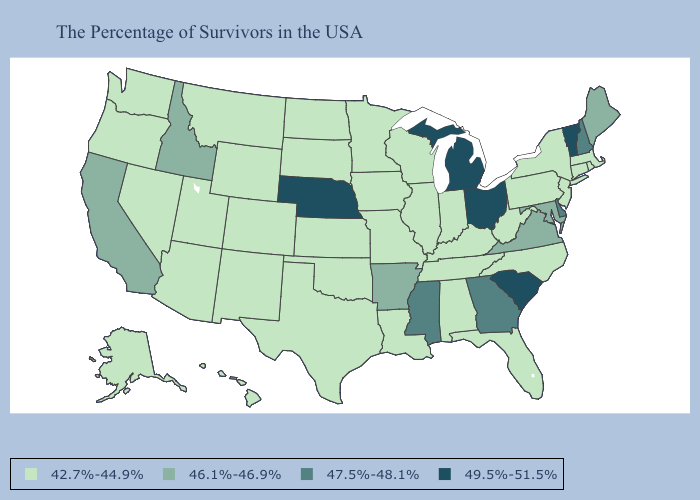Which states have the lowest value in the South?
Give a very brief answer. North Carolina, West Virginia, Florida, Kentucky, Alabama, Tennessee, Louisiana, Oklahoma, Texas. Among the states that border Washington , does Oregon have the highest value?
Short answer required. No. What is the value of Illinois?
Quick response, please. 42.7%-44.9%. What is the lowest value in states that border Nevada?
Quick response, please. 42.7%-44.9%. Which states hav the highest value in the MidWest?
Be succinct. Ohio, Michigan, Nebraska. Name the states that have a value in the range 46.1%-46.9%?
Write a very short answer. Maine, Maryland, Virginia, Arkansas, Idaho, California. Does Delaware have the lowest value in the South?
Short answer required. No. Does Nebraska have a higher value than Rhode Island?
Be succinct. Yes. What is the highest value in the USA?
Write a very short answer. 49.5%-51.5%. What is the value of Kentucky?
Quick response, please. 42.7%-44.9%. How many symbols are there in the legend?
Write a very short answer. 4. Does Nebraska have the lowest value in the USA?
Quick response, please. No. Is the legend a continuous bar?
Answer briefly. No. Which states have the lowest value in the West?
Concise answer only. Wyoming, Colorado, New Mexico, Utah, Montana, Arizona, Nevada, Washington, Oregon, Alaska, Hawaii. Name the states that have a value in the range 49.5%-51.5%?
Be succinct. Vermont, South Carolina, Ohio, Michigan, Nebraska. 